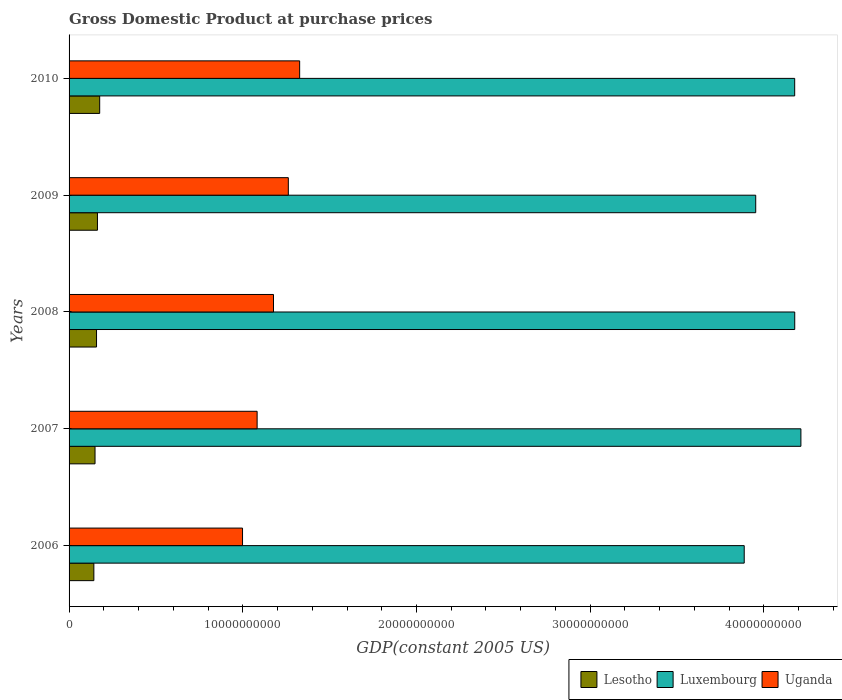Are the number of bars on each tick of the Y-axis equal?
Provide a short and direct response. Yes. What is the label of the 2nd group of bars from the top?
Give a very brief answer. 2009. In how many cases, is the number of bars for a given year not equal to the number of legend labels?
Ensure brevity in your answer.  0. What is the GDP at purchase prices in Lesotho in 2009?
Offer a terse response. 1.63e+09. Across all years, what is the maximum GDP at purchase prices in Uganda?
Ensure brevity in your answer.  1.33e+1. Across all years, what is the minimum GDP at purchase prices in Uganda?
Provide a succinct answer. 9.99e+09. In which year was the GDP at purchase prices in Luxembourg minimum?
Your answer should be compact. 2006. What is the total GDP at purchase prices in Luxembourg in the graph?
Your answer should be compact. 2.04e+11. What is the difference between the GDP at purchase prices in Lesotho in 2008 and that in 2010?
Offer a terse response. -1.82e+08. What is the difference between the GDP at purchase prices in Luxembourg in 2010 and the GDP at purchase prices in Lesotho in 2009?
Make the answer very short. 4.01e+1. What is the average GDP at purchase prices in Lesotho per year?
Your response must be concise. 1.58e+09. In the year 2009, what is the difference between the GDP at purchase prices in Lesotho and GDP at purchase prices in Luxembourg?
Keep it short and to the point. -3.79e+1. What is the ratio of the GDP at purchase prices in Uganda in 2006 to that in 2010?
Give a very brief answer. 0.75. Is the difference between the GDP at purchase prices in Lesotho in 2006 and 2008 greater than the difference between the GDP at purchase prices in Luxembourg in 2006 and 2008?
Keep it short and to the point. Yes. What is the difference between the highest and the second highest GDP at purchase prices in Luxembourg?
Your response must be concise. 3.55e+08. What is the difference between the highest and the lowest GDP at purchase prices in Lesotho?
Ensure brevity in your answer.  3.35e+08. What does the 3rd bar from the top in 2010 represents?
Provide a succinct answer. Lesotho. What does the 3rd bar from the bottom in 2010 represents?
Offer a very short reply. Uganda. How many bars are there?
Your response must be concise. 15. Are all the bars in the graph horizontal?
Offer a terse response. Yes. What is the difference between two consecutive major ticks on the X-axis?
Your response must be concise. 1.00e+1. Are the values on the major ticks of X-axis written in scientific E-notation?
Provide a succinct answer. No. Does the graph contain any zero values?
Give a very brief answer. No. How many legend labels are there?
Your answer should be very brief. 3. How are the legend labels stacked?
Your answer should be very brief. Horizontal. What is the title of the graph?
Provide a succinct answer. Gross Domestic Product at purchase prices. Does "Ecuador" appear as one of the legend labels in the graph?
Your response must be concise. No. What is the label or title of the X-axis?
Make the answer very short. GDP(constant 2005 US). What is the label or title of the Y-axis?
Your answer should be very brief. Years. What is the GDP(constant 2005 US) of Lesotho in 2006?
Your answer should be very brief. 1.43e+09. What is the GDP(constant 2005 US) of Luxembourg in 2006?
Offer a very short reply. 3.89e+1. What is the GDP(constant 2005 US) of Uganda in 2006?
Offer a very short reply. 9.99e+09. What is the GDP(constant 2005 US) of Lesotho in 2007?
Give a very brief answer. 1.49e+09. What is the GDP(constant 2005 US) of Luxembourg in 2007?
Give a very brief answer. 4.21e+1. What is the GDP(constant 2005 US) of Uganda in 2007?
Offer a terse response. 1.08e+1. What is the GDP(constant 2005 US) in Lesotho in 2008?
Offer a very short reply. 1.58e+09. What is the GDP(constant 2005 US) of Luxembourg in 2008?
Provide a short and direct response. 4.18e+1. What is the GDP(constant 2005 US) of Uganda in 2008?
Offer a very short reply. 1.18e+1. What is the GDP(constant 2005 US) of Lesotho in 2009?
Your answer should be very brief. 1.63e+09. What is the GDP(constant 2005 US) of Luxembourg in 2009?
Make the answer very short. 3.95e+1. What is the GDP(constant 2005 US) in Uganda in 2009?
Ensure brevity in your answer.  1.26e+1. What is the GDP(constant 2005 US) of Lesotho in 2010?
Make the answer very short. 1.76e+09. What is the GDP(constant 2005 US) in Luxembourg in 2010?
Ensure brevity in your answer.  4.18e+1. What is the GDP(constant 2005 US) of Uganda in 2010?
Provide a short and direct response. 1.33e+1. Across all years, what is the maximum GDP(constant 2005 US) in Lesotho?
Your response must be concise. 1.76e+09. Across all years, what is the maximum GDP(constant 2005 US) of Luxembourg?
Your response must be concise. 4.21e+1. Across all years, what is the maximum GDP(constant 2005 US) in Uganda?
Offer a terse response. 1.33e+1. Across all years, what is the minimum GDP(constant 2005 US) in Lesotho?
Your answer should be compact. 1.43e+09. Across all years, what is the minimum GDP(constant 2005 US) of Luxembourg?
Offer a terse response. 3.89e+1. Across all years, what is the minimum GDP(constant 2005 US) of Uganda?
Your answer should be very brief. 9.99e+09. What is the total GDP(constant 2005 US) of Lesotho in the graph?
Your answer should be very brief. 7.90e+09. What is the total GDP(constant 2005 US) in Luxembourg in the graph?
Offer a terse response. 2.04e+11. What is the total GDP(constant 2005 US) in Uganda in the graph?
Your response must be concise. 5.85e+1. What is the difference between the GDP(constant 2005 US) of Lesotho in 2006 and that in 2007?
Your answer should be very brief. -6.76e+07. What is the difference between the GDP(constant 2005 US) of Luxembourg in 2006 and that in 2007?
Ensure brevity in your answer.  -3.26e+09. What is the difference between the GDP(constant 2005 US) in Uganda in 2006 and that in 2007?
Offer a very short reply. -8.40e+08. What is the difference between the GDP(constant 2005 US) in Lesotho in 2006 and that in 2008?
Your answer should be very brief. -1.53e+08. What is the difference between the GDP(constant 2005 US) in Luxembourg in 2006 and that in 2008?
Keep it short and to the point. -2.91e+09. What is the difference between the GDP(constant 2005 US) of Uganda in 2006 and that in 2008?
Give a very brief answer. -1.78e+09. What is the difference between the GDP(constant 2005 US) of Lesotho in 2006 and that in 2009?
Your answer should be very brief. -2.06e+08. What is the difference between the GDP(constant 2005 US) of Luxembourg in 2006 and that in 2009?
Provide a short and direct response. -6.62e+08. What is the difference between the GDP(constant 2005 US) of Uganda in 2006 and that in 2009?
Offer a terse response. -2.64e+09. What is the difference between the GDP(constant 2005 US) in Lesotho in 2006 and that in 2010?
Your answer should be compact. -3.35e+08. What is the difference between the GDP(constant 2005 US) of Luxembourg in 2006 and that in 2010?
Offer a very short reply. -2.91e+09. What is the difference between the GDP(constant 2005 US) in Uganda in 2006 and that in 2010?
Offer a terse response. -3.29e+09. What is the difference between the GDP(constant 2005 US) in Lesotho in 2007 and that in 2008?
Make the answer very short. -8.57e+07. What is the difference between the GDP(constant 2005 US) of Luxembourg in 2007 and that in 2008?
Make the answer very short. 3.55e+08. What is the difference between the GDP(constant 2005 US) in Uganda in 2007 and that in 2008?
Your response must be concise. -9.43e+08. What is the difference between the GDP(constant 2005 US) in Lesotho in 2007 and that in 2009?
Ensure brevity in your answer.  -1.39e+08. What is the difference between the GDP(constant 2005 US) of Luxembourg in 2007 and that in 2009?
Make the answer very short. 2.60e+09. What is the difference between the GDP(constant 2005 US) of Uganda in 2007 and that in 2009?
Your response must be concise. -1.80e+09. What is the difference between the GDP(constant 2005 US) of Lesotho in 2007 and that in 2010?
Ensure brevity in your answer.  -2.68e+08. What is the difference between the GDP(constant 2005 US) in Luxembourg in 2007 and that in 2010?
Make the answer very short. 3.58e+08. What is the difference between the GDP(constant 2005 US) of Uganda in 2007 and that in 2010?
Ensure brevity in your answer.  -2.45e+09. What is the difference between the GDP(constant 2005 US) in Lesotho in 2008 and that in 2009?
Give a very brief answer. -5.31e+07. What is the difference between the GDP(constant 2005 US) in Luxembourg in 2008 and that in 2009?
Give a very brief answer. 2.25e+09. What is the difference between the GDP(constant 2005 US) in Uganda in 2008 and that in 2009?
Offer a very short reply. -8.53e+08. What is the difference between the GDP(constant 2005 US) of Lesotho in 2008 and that in 2010?
Offer a terse response. -1.82e+08. What is the difference between the GDP(constant 2005 US) in Luxembourg in 2008 and that in 2010?
Provide a short and direct response. 2.33e+06. What is the difference between the GDP(constant 2005 US) in Uganda in 2008 and that in 2010?
Keep it short and to the point. -1.51e+09. What is the difference between the GDP(constant 2005 US) of Lesotho in 2009 and that in 2010?
Provide a succinct answer. -1.29e+08. What is the difference between the GDP(constant 2005 US) of Luxembourg in 2009 and that in 2010?
Ensure brevity in your answer.  -2.24e+09. What is the difference between the GDP(constant 2005 US) in Uganda in 2009 and that in 2010?
Offer a terse response. -6.53e+08. What is the difference between the GDP(constant 2005 US) in Lesotho in 2006 and the GDP(constant 2005 US) in Luxembourg in 2007?
Give a very brief answer. -4.07e+1. What is the difference between the GDP(constant 2005 US) of Lesotho in 2006 and the GDP(constant 2005 US) of Uganda in 2007?
Offer a very short reply. -9.40e+09. What is the difference between the GDP(constant 2005 US) in Luxembourg in 2006 and the GDP(constant 2005 US) in Uganda in 2007?
Your response must be concise. 2.80e+1. What is the difference between the GDP(constant 2005 US) in Lesotho in 2006 and the GDP(constant 2005 US) in Luxembourg in 2008?
Your response must be concise. -4.03e+1. What is the difference between the GDP(constant 2005 US) in Lesotho in 2006 and the GDP(constant 2005 US) in Uganda in 2008?
Your response must be concise. -1.03e+1. What is the difference between the GDP(constant 2005 US) in Luxembourg in 2006 and the GDP(constant 2005 US) in Uganda in 2008?
Ensure brevity in your answer.  2.71e+1. What is the difference between the GDP(constant 2005 US) of Lesotho in 2006 and the GDP(constant 2005 US) of Luxembourg in 2009?
Give a very brief answer. -3.81e+1. What is the difference between the GDP(constant 2005 US) in Lesotho in 2006 and the GDP(constant 2005 US) in Uganda in 2009?
Ensure brevity in your answer.  -1.12e+1. What is the difference between the GDP(constant 2005 US) of Luxembourg in 2006 and the GDP(constant 2005 US) of Uganda in 2009?
Provide a succinct answer. 2.62e+1. What is the difference between the GDP(constant 2005 US) in Lesotho in 2006 and the GDP(constant 2005 US) in Luxembourg in 2010?
Give a very brief answer. -4.03e+1. What is the difference between the GDP(constant 2005 US) of Lesotho in 2006 and the GDP(constant 2005 US) of Uganda in 2010?
Your response must be concise. -1.18e+1. What is the difference between the GDP(constant 2005 US) of Luxembourg in 2006 and the GDP(constant 2005 US) of Uganda in 2010?
Ensure brevity in your answer.  2.56e+1. What is the difference between the GDP(constant 2005 US) in Lesotho in 2007 and the GDP(constant 2005 US) in Luxembourg in 2008?
Ensure brevity in your answer.  -4.03e+1. What is the difference between the GDP(constant 2005 US) of Lesotho in 2007 and the GDP(constant 2005 US) of Uganda in 2008?
Make the answer very short. -1.03e+1. What is the difference between the GDP(constant 2005 US) of Luxembourg in 2007 and the GDP(constant 2005 US) of Uganda in 2008?
Your response must be concise. 3.04e+1. What is the difference between the GDP(constant 2005 US) of Lesotho in 2007 and the GDP(constant 2005 US) of Luxembourg in 2009?
Provide a succinct answer. -3.80e+1. What is the difference between the GDP(constant 2005 US) in Lesotho in 2007 and the GDP(constant 2005 US) in Uganda in 2009?
Ensure brevity in your answer.  -1.11e+1. What is the difference between the GDP(constant 2005 US) of Luxembourg in 2007 and the GDP(constant 2005 US) of Uganda in 2009?
Provide a succinct answer. 2.95e+1. What is the difference between the GDP(constant 2005 US) of Lesotho in 2007 and the GDP(constant 2005 US) of Luxembourg in 2010?
Your response must be concise. -4.03e+1. What is the difference between the GDP(constant 2005 US) of Lesotho in 2007 and the GDP(constant 2005 US) of Uganda in 2010?
Your answer should be compact. -1.18e+1. What is the difference between the GDP(constant 2005 US) in Luxembourg in 2007 and the GDP(constant 2005 US) in Uganda in 2010?
Your response must be concise. 2.89e+1. What is the difference between the GDP(constant 2005 US) in Lesotho in 2008 and the GDP(constant 2005 US) in Luxembourg in 2009?
Provide a short and direct response. -3.79e+1. What is the difference between the GDP(constant 2005 US) of Lesotho in 2008 and the GDP(constant 2005 US) of Uganda in 2009?
Provide a succinct answer. -1.10e+1. What is the difference between the GDP(constant 2005 US) of Luxembourg in 2008 and the GDP(constant 2005 US) of Uganda in 2009?
Give a very brief answer. 2.92e+1. What is the difference between the GDP(constant 2005 US) of Lesotho in 2008 and the GDP(constant 2005 US) of Luxembourg in 2010?
Offer a terse response. -4.02e+1. What is the difference between the GDP(constant 2005 US) of Lesotho in 2008 and the GDP(constant 2005 US) of Uganda in 2010?
Keep it short and to the point. -1.17e+1. What is the difference between the GDP(constant 2005 US) in Luxembourg in 2008 and the GDP(constant 2005 US) in Uganda in 2010?
Offer a terse response. 2.85e+1. What is the difference between the GDP(constant 2005 US) of Lesotho in 2009 and the GDP(constant 2005 US) of Luxembourg in 2010?
Your answer should be very brief. -4.01e+1. What is the difference between the GDP(constant 2005 US) in Lesotho in 2009 and the GDP(constant 2005 US) in Uganda in 2010?
Ensure brevity in your answer.  -1.16e+1. What is the difference between the GDP(constant 2005 US) of Luxembourg in 2009 and the GDP(constant 2005 US) of Uganda in 2010?
Provide a succinct answer. 2.63e+1. What is the average GDP(constant 2005 US) in Lesotho per year?
Give a very brief answer. 1.58e+09. What is the average GDP(constant 2005 US) in Luxembourg per year?
Provide a succinct answer. 4.08e+1. What is the average GDP(constant 2005 US) in Uganda per year?
Offer a terse response. 1.17e+1. In the year 2006, what is the difference between the GDP(constant 2005 US) of Lesotho and GDP(constant 2005 US) of Luxembourg?
Provide a succinct answer. -3.74e+1. In the year 2006, what is the difference between the GDP(constant 2005 US) of Lesotho and GDP(constant 2005 US) of Uganda?
Provide a short and direct response. -8.56e+09. In the year 2006, what is the difference between the GDP(constant 2005 US) in Luxembourg and GDP(constant 2005 US) in Uganda?
Provide a short and direct response. 2.89e+1. In the year 2007, what is the difference between the GDP(constant 2005 US) of Lesotho and GDP(constant 2005 US) of Luxembourg?
Offer a very short reply. -4.06e+1. In the year 2007, what is the difference between the GDP(constant 2005 US) in Lesotho and GDP(constant 2005 US) in Uganda?
Your response must be concise. -9.33e+09. In the year 2007, what is the difference between the GDP(constant 2005 US) of Luxembourg and GDP(constant 2005 US) of Uganda?
Ensure brevity in your answer.  3.13e+1. In the year 2008, what is the difference between the GDP(constant 2005 US) in Lesotho and GDP(constant 2005 US) in Luxembourg?
Offer a terse response. -4.02e+1. In the year 2008, what is the difference between the GDP(constant 2005 US) in Lesotho and GDP(constant 2005 US) in Uganda?
Provide a succinct answer. -1.02e+1. In the year 2008, what is the difference between the GDP(constant 2005 US) of Luxembourg and GDP(constant 2005 US) of Uganda?
Offer a very short reply. 3.00e+1. In the year 2009, what is the difference between the GDP(constant 2005 US) in Lesotho and GDP(constant 2005 US) in Luxembourg?
Keep it short and to the point. -3.79e+1. In the year 2009, what is the difference between the GDP(constant 2005 US) in Lesotho and GDP(constant 2005 US) in Uganda?
Provide a succinct answer. -1.10e+1. In the year 2009, what is the difference between the GDP(constant 2005 US) in Luxembourg and GDP(constant 2005 US) in Uganda?
Your answer should be compact. 2.69e+1. In the year 2010, what is the difference between the GDP(constant 2005 US) in Lesotho and GDP(constant 2005 US) in Luxembourg?
Your response must be concise. -4.00e+1. In the year 2010, what is the difference between the GDP(constant 2005 US) of Lesotho and GDP(constant 2005 US) of Uganda?
Provide a short and direct response. -1.15e+1. In the year 2010, what is the difference between the GDP(constant 2005 US) in Luxembourg and GDP(constant 2005 US) in Uganda?
Offer a terse response. 2.85e+1. What is the ratio of the GDP(constant 2005 US) in Lesotho in 2006 to that in 2007?
Provide a succinct answer. 0.95. What is the ratio of the GDP(constant 2005 US) of Luxembourg in 2006 to that in 2007?
Give a very brief answer. 0.92. What is the ratio of the GDP(constant 2005 US) of Uganda in 2006 to that in 2007?
Your answer should be compact. 0.92. What is the ratio of the GDP(constant 2005 US) of Lesotho in 2006 to that in 2008?
Your response must be concise. 0.9. What is the ratio of the GDP(constant 2005 US) in Luxembourg in 2006 to that in 2008?
Keep it short and to the point. 0.93. What is the ratio of the GDP(constant 2005 US) in Uganda in 2006 to that in 2008?
Give a very brief answer. 0.85. What is the ratio of the GDP(constant 2005 US) in Lesotho in 2006 to that in 2009?
Give a very brief answer. 0.87. What is the ratio of the GDP(constant 2005 US) of Luxembourg in 2006 to that in 2009?
Provide a short and direct response. 0.98. What is the ratio of the GDP(constant 2005 US) of Uganda in 2006 to that in 2009?
Provide a succinct answer. 0.79. What is the ratio of the GDP(constant 2005 US) in Lesotho in 2006 to that in 2010?
Your answer should be compact. 0.81. What is the ratio of the GDP(constant 2005 US) in Luxembourg in 2006 to that in 2010?
Make the answer very short. 0.93. What is the ratio of the GDP(constant 2005 US) in Uganda in 2006 to that in 2010?
Provide a short and direct response. 0.75. What is the ratio of the GDP(constant 2005 US) in Lesotho in 2007 to that in 2008?
Provide a succinct answer. 0.95. What is the ratio of the GDP(constant 2005 US) in Luxembourg in 2007 to that in 2008?
Offer a terse response. 1.01. What is the ratio of the GDP(constant 2005 US) of Uganda in 2007 to that in 2008?
Your response must be concise. 0.92. What is the ratio of the GDP(constant 2005 US) of Lesotho in 2007 to that in 2009?
Keep it short and to the point. 0.92. What is the ratio of the GDP(constant 2005 US) of Luxembourg in 2007 to that in 2009?
Make the answer very short. 1.07. What is the ratio of the GDP(constant 2005 US) in Uganda in 2007 to that in 2009?
Your response must be concise. 0.86. What is the ratio of the GDP(constant 2005 US) in Lesotho in 2007 to that in 2010?
Keep it short and to the point. 0.85. What is the ratio of the GDP(constant 2005 US) in Luxembourg in 2007 to that in 2010?
Ensure brevity in your answer.  1.01. What is the ratio of the GDP(constant 2005 US) in Uganda in 2007 to that in 2010?
Offer a terse response. 0.82. What is the ratio of the GDP(constant 2005 US) of Lesotho in 2008 to that in 2009?
Give a very brief answer. 0.97. What is the ratio of the GDP(constant 2005 US) in Luxembourg in 2008 to that in 2009?
Give a very brief answer. 1.06. What is the ratio of the GDP(constant 2005 US) in Uganda in 2008 to that in 2009?
Give a very brief answer. 0.93. What is the ratio of the GDP(constant 2005 US) in Lesotho in 2008 to that in 2010?
Your response must be concise. 0.9. What is the ratio of the GDP(constant 2005 US) in Uganda in 2008 to that in 2010?
Keep it short and to the point. 0.89. What is the ratio of the GDP(constant 2005 US) in Lesotho in 2009 to that in 2010?
Provide a succinct answer. 0.93. What is the ratio of the GDP(constant 2005 US) of Luxembourg in 2009 to that in 2010?
Your answer should be compact. 0.95. What is the ratio of the GDP(constant 2005 US) of Uganda in 2009 to that in 2010?
Give a very brief answer. 0.95. What is the difference between the highest and the second highest GDP(constant 2005 US) of Lesotho?
Provide a succinct answer. 1.29e+08. What is the difference between the highest and the second highest GDP(constant 2005 US) of Luxembourg?
Offer a terse response. 3.55e+08. What is the difference between the highest and the second highest GDP(constant 2005 US) in Uganda?
Ensure brevity in your answer.  6.53e+08. What is the difference between the highest and the lowest GDP(constant 2005 US) of Lesotho?
Make the answer very short. 3.35e+08. What is the difference between the highest and the lowest GDP(constant 2005 US) of Luxembourg?
Offer a very short reply. 3.26e+09. What is the difference between the highest and the lowest GDP(constant 2005 US) of Uganda?
Your answer should be very brief. 3.29e+09. 